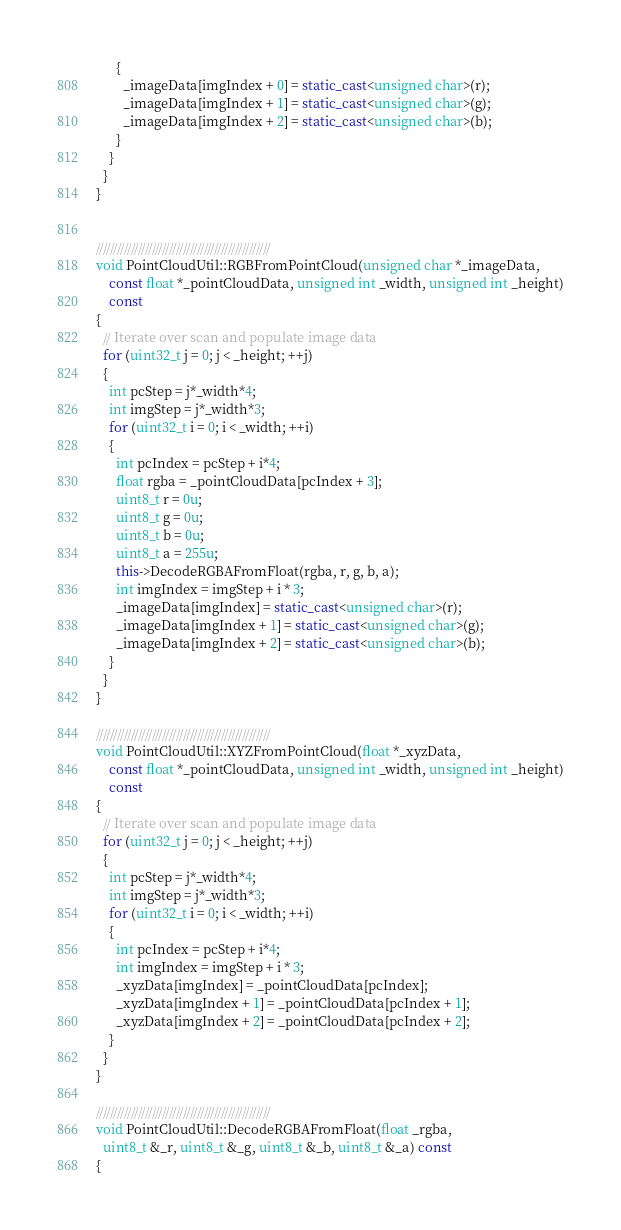<code> <loc_0><loc_0><loc_500><loc_500><_C++_>      {
        _imageData[imgIndex + 0] = static_cast<unsigned char>(r);
        _imageData[imgIndex + 1] = static_cast<unsigned char>(g);
        _imageData[imgIndex + 2] = static_cast<unsigned char>(b);
      }
    }
  }
}


//////////////////////////////////////////////////
void PointCloudUtil::RGBFromPointCloud(unsigned char *_imageData,
    const float *_pointCloudData, unsigned int _width, unsigned int _height)
    const
{
  // Iterate over scan and populate image data
  for (uint32_t j = 0; j < _height; ++j)
  {
    int pcStep = j*_width*4;
    int imgStep = j*_width*3;
    for (uint32_t i = 0; i < _width; ++i)
    {
      int pcIndex = pcStep + i*4;
      float rgba = _pointCloudData[pcIndex + 3];
      uint8_t r = 0u;
      uint8_t g = 0u;
      uint8_t b = 0u;
      uint8_t a = 255u;
      this->DecodeRGBAFromFloat(rgba, r, g, b, a);
      int imgIndex = imgStep + i * 3;
      _imageData[imgIndex] = static_cast<unsigned char>(r);
      _imageData[imgIndex + 1] = static_cast<unsigned char>(g);
      _imageData[imgIndex + 2] = static_cast<unsigned char>(b);
    }
  }
}

//////////////////////////////////////////////////
void PointCloudUtil::XYZFromPointCloud(float *_xyzData,
    const float *_pointCloudData, unsigned int _width, unsigned int _height)
    const
{
  // Iterate over scan and populate image data
  for (uint32_t j = 0; j < _height; ++j)
  {
    int pcStep = j*_width*4;
    int imgStep = j*_width*3;
    for (uint32_t i = 0; i < _width; ++i)
    {
      int pcIndex = pcStep + i*4;
      int imgIndex = imgStep + i * 3;
      _xyzData[imgIndex] = _pointCloudData[pcIndex];
      _xyzData[imgIndex + 1] = _pointCloudData[pcIndex + 1];
      _xyzData[imgIndex + 2] = _pointCloudData[pcIndex + 2];
    }
  }
}

//////////////////////////////////////////////////
void PointCloudUtil::DecodeRGBAFromFloat(float _rgba,
  uint8_t &_r, uint8_t &_g, uint8_t &_b, uint8_t &_a) const
{</code> 